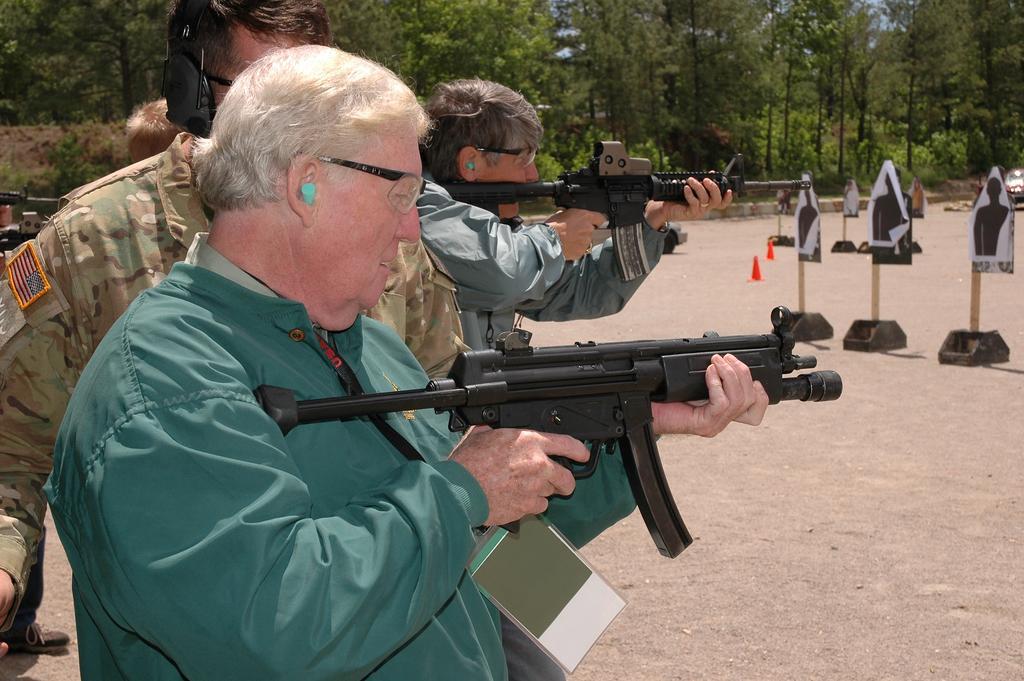Could you give a brief overview of what you see in this image? In this image we can see some group of persons wearing jackets and camouflage dress, people wearing jackets holding weapons in their hands, on right side of the image there is shooting target and in the background of the image there are some trees. 